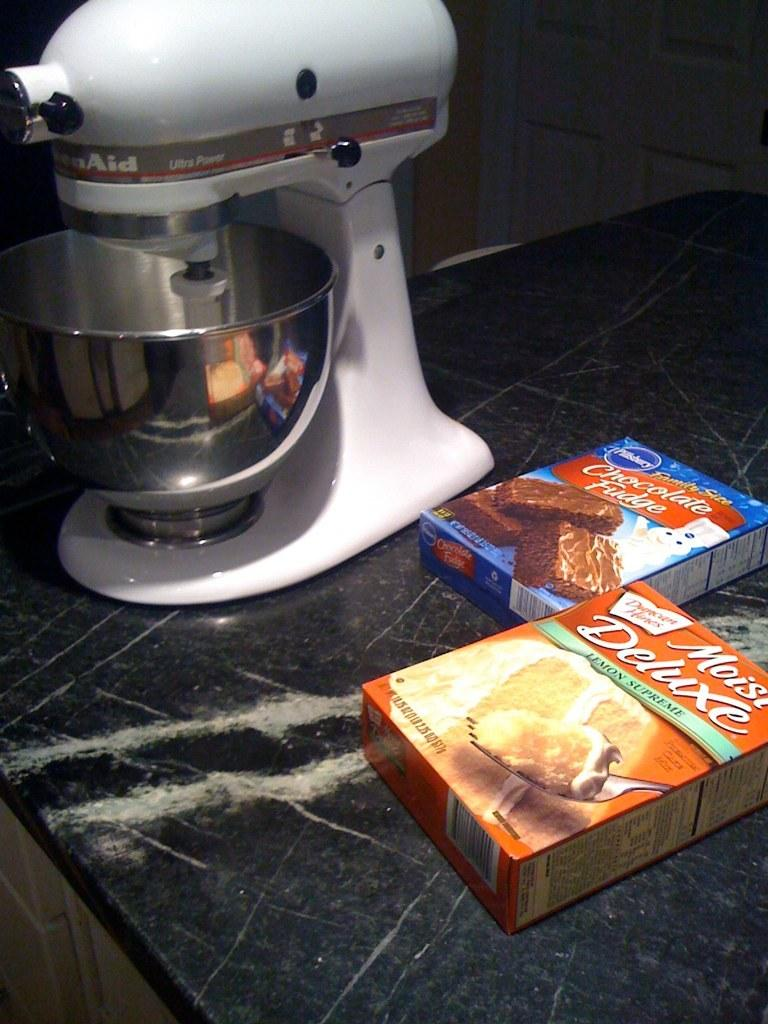<image>
Share a concise interpretation of the image provided. 2 boxes of cake mix are labeled chocolate fudge and moist deluxe. 